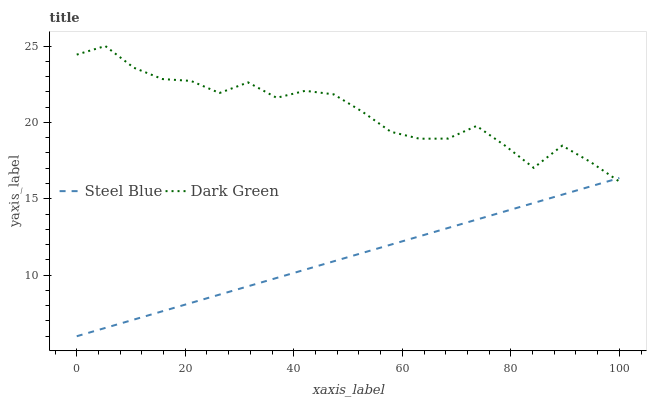Does Steel Blue have the minimum area under the curve?
Answer yes or no. Yes. Does Dark Green have the maximum area under the curve?
Answer yes or no. Yes. Does Dark Green have the minimum area under the curve?
Answer yes or no. No. Is Steel Blue the smoothest?
Answer yes or no. Yes. Is Dark Green the roughest?
Answer yes or no. Yes. Is Dark Green the smoothest?
Answer yes or no. No. Does Steel Blue have the lowest value?
Answer yes or no. Yes. Does Dark Green have the lowest value?
Answer yes or no. No. Does Dark Green have the highest value?
Answer yes or no. Yes. Does Dark Green intersect Steel Blue?
Answer yes or no. Yes. Is Dark Green less than Steel Blue?
Answer yes or no. No. Is Dark Green greater than Steel Blue?
Answer yes or no. No. 